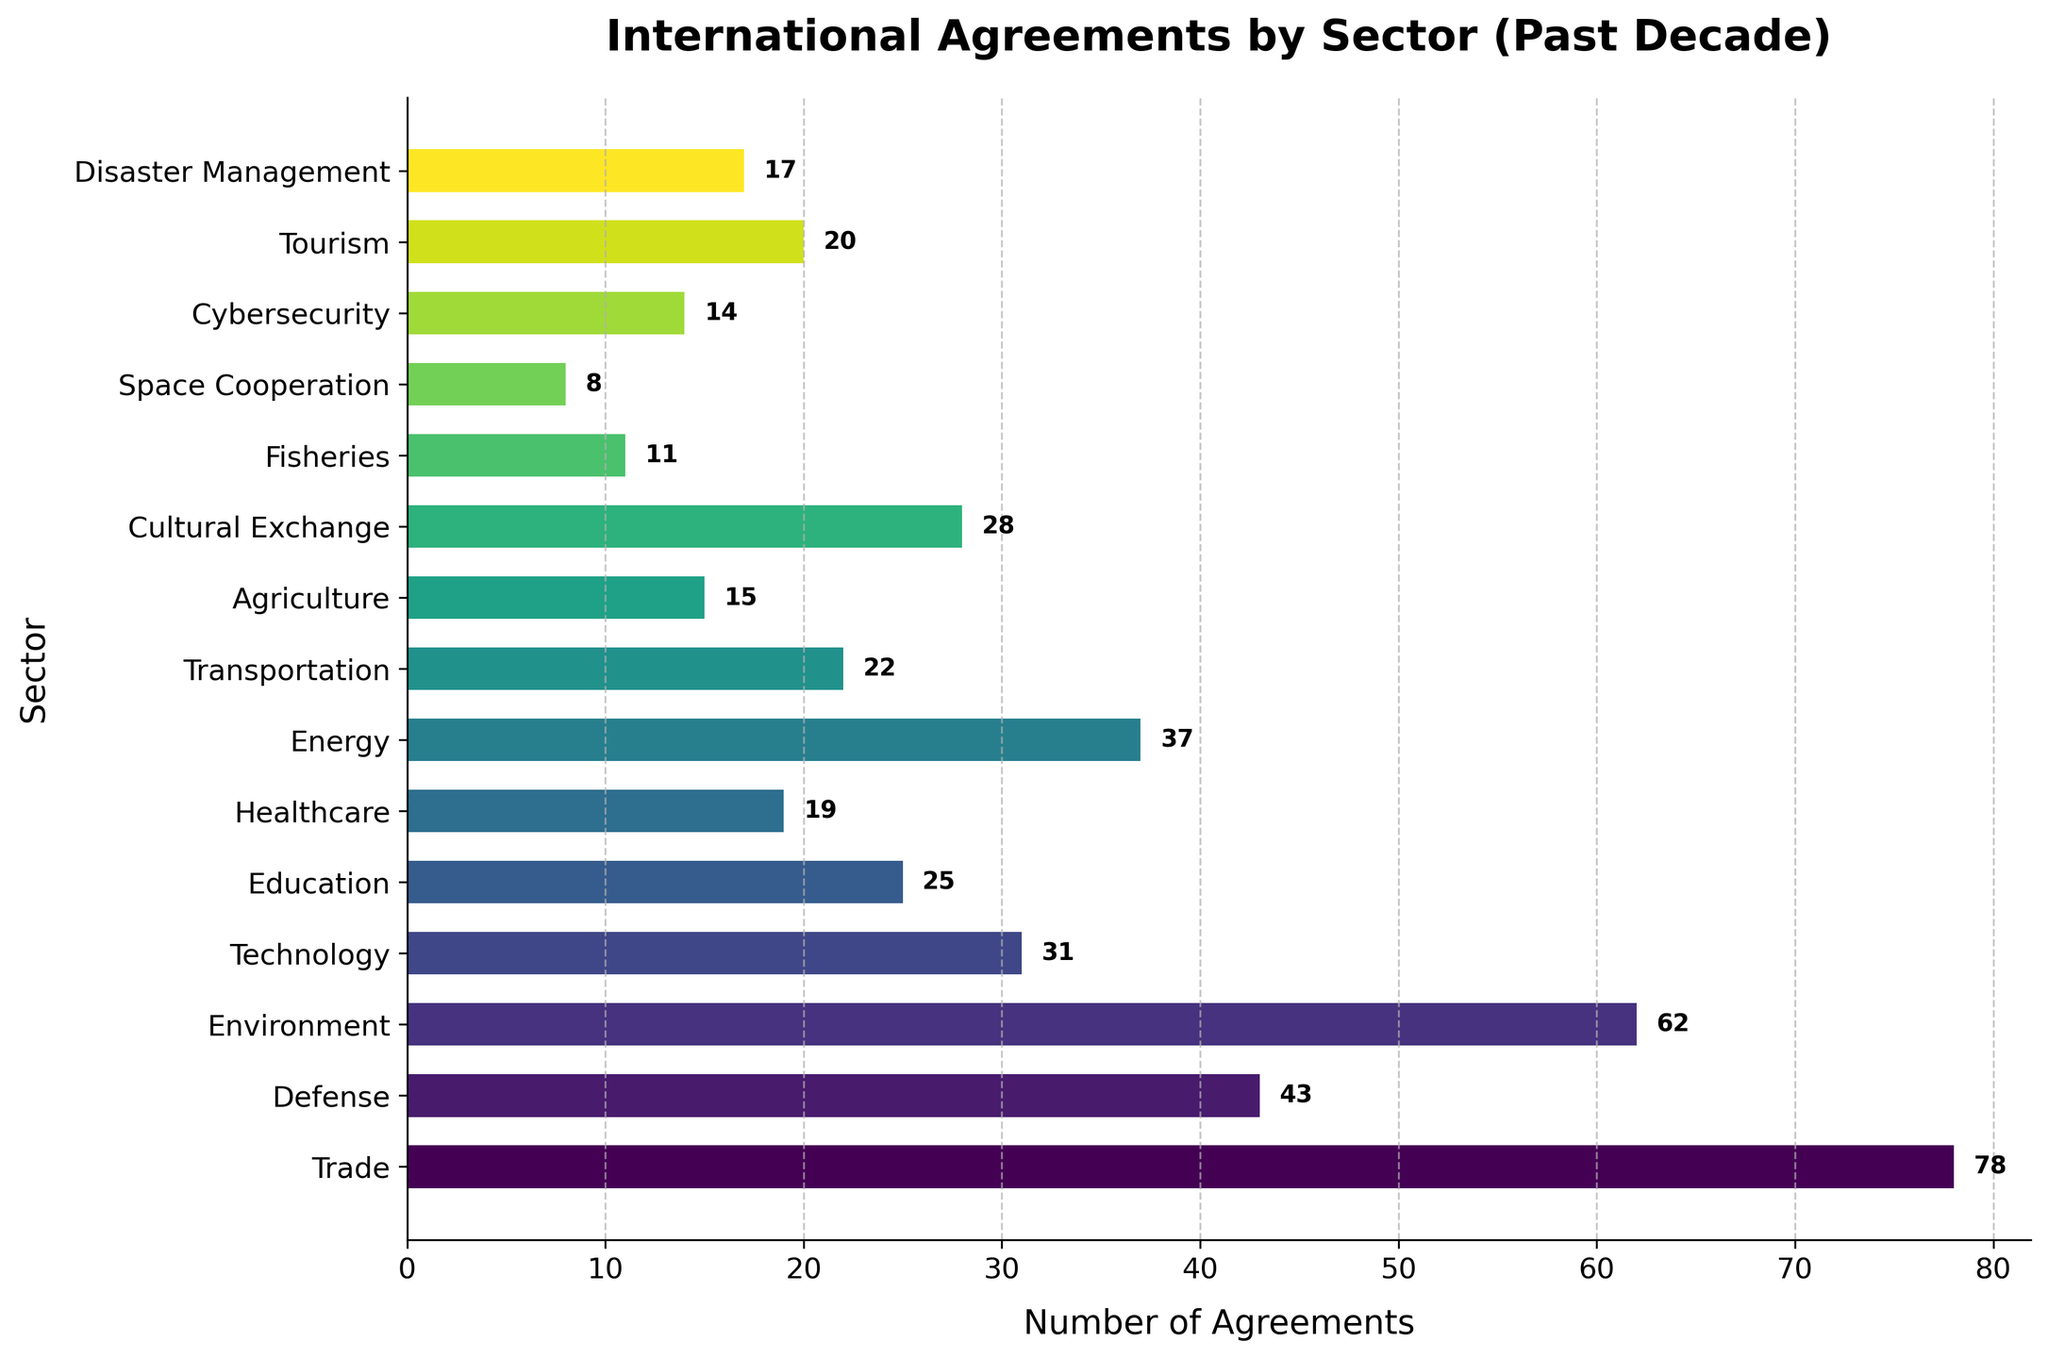Which sector signed the most international agreements in the past decade? The bar chart shows the numbers of agreements for each sector, and the longest bar represents the sector with the most agreements.
Answer: Trade What is the total number of agreements signed in the Trade and Environment sectors combined? The number of agreements in the Trade sector is 78, and in the Environment sector is 62. Adding these together, we get 78 + 62.
Answer: 140 Which sector has fewer agreements, Education or Transportation? By comparing the lengths of the bars labeled Education and Transportation, we can see that Education has fewer agreements (25) than Transportation (22).
Answer: Transportation How many more agreements are there in the Defense sector compared to the Cybersecurity sector? The bar for the Defense sector shows 43 agreements, and the bar for the Cybersecurity sector shows 14 agreements. Subtracting these gives 43 - 14.
Answer: 29 Which two sectors have the closest number of agreements, and what are those numbers? By comparing the lengths of all the bars, we see that Disaster Management and Cybersecurity have similar lengths with 17 and 14 agreements respectively.
Answer: Disaster Management (17) and Cybersecurity (14) What is the average number of agreements across the Technology, Education, and Healthcare sectors? The number of agreements in Technology is 31, in Education is 25, and in Healthcare is 19. The sum is 31 + 25 + 19 = 75. Dividing by 3, the average is 75 / 3.
Answer: 25 Which sector has the least number of agreements signed? The shortest bar in the chart corresponds to the sector with the least number of agreements.
Answer: Space Cooperation What is the combined total of agreements in the top three sectors with the most agreements? The top three sectors are Trade (78), Environment (62), and Defense (43). Adding these gives 78 + 62 + 43.
Answer: 183 How many sectors have signed more than 30 agreements? Counting the bars with numbers greater than 30, we see Trade (78), Environment (62), Defense (43), Technology (31), and Energy (37).
Answer: 5 